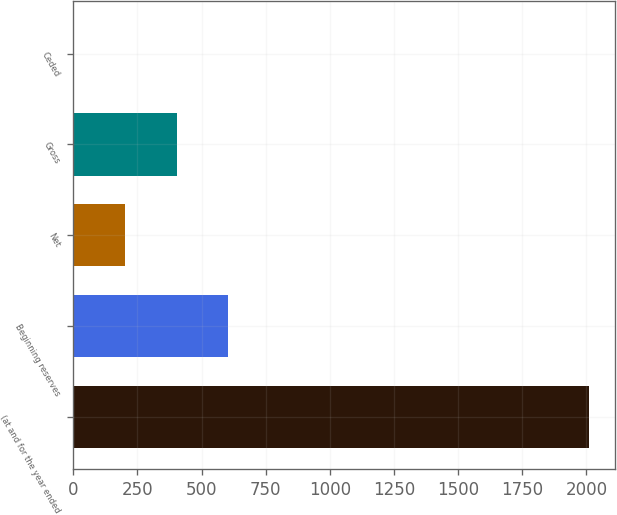<chart> <loc_0><loc_0><loc_500><loc_500><bar_chart><fcel>(at and for the year ended<fcel>Beginning reserves<fcel>Net<fcel>Gross<fcel>Ceded<nl><fcel>2011<fcel>604.7<fcel>202.9<fcel>403.8<fcel>2<nl></chart> 